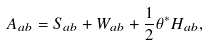<formula> <loc_0><loc_0><loc_500><loc_500>A _ { a b } = S _ { a b } + W _ { a b } + \frac { 1 } { 2 } \theta ^ { * } H _ { a b } ,</formula> 